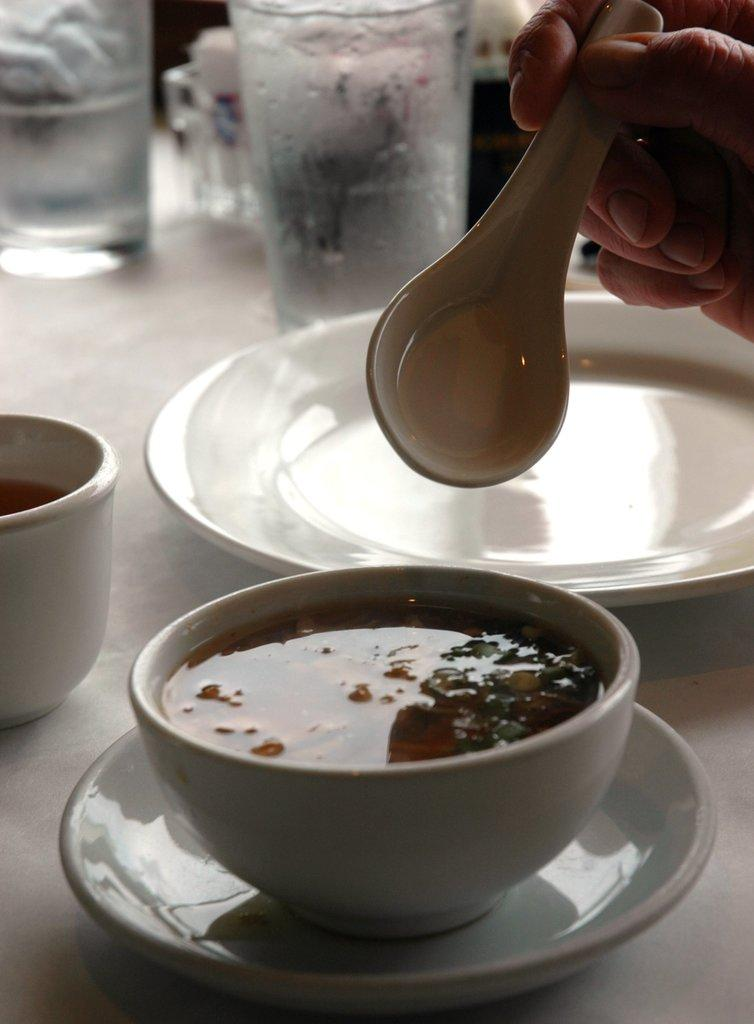What is in the bowl that is visible in the image? There is a bowl of soup in the image. Where is the bowl of soup located? The bowl of soup is placed on a table. What is the person in the image using to eat the soup? There is a hand holding a spoon in the image. What beverage is visible in the image? There is a glass of water in the image. What type of riddle is the beetle solving in the image? There is no beetle or riddle present in the image. How does the wave affect the soup in the image? There is no wave present in the image, so it cannot affect the soup. 